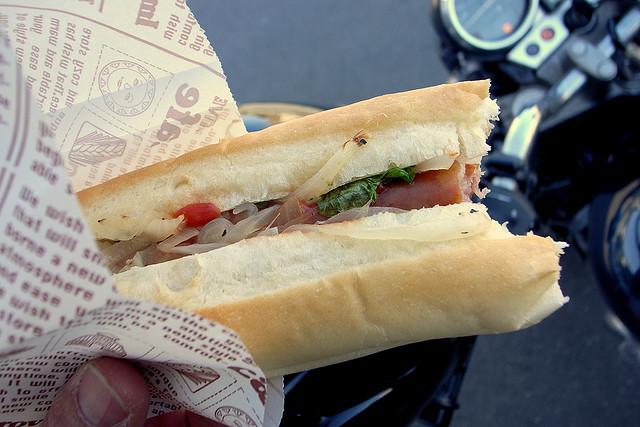Are there napkins?
Short answer required. No. What kind of food is this?
Concise answer only. Sandwich. What kind of sub is this?
Concise answer only. Hot dog. What is around the frankfurter?
Quick response, please. Bun. What is the person standing by?
Quick response, please. Motorcycle. Does this sandwich have egg?
Give a very brief answer. No. 